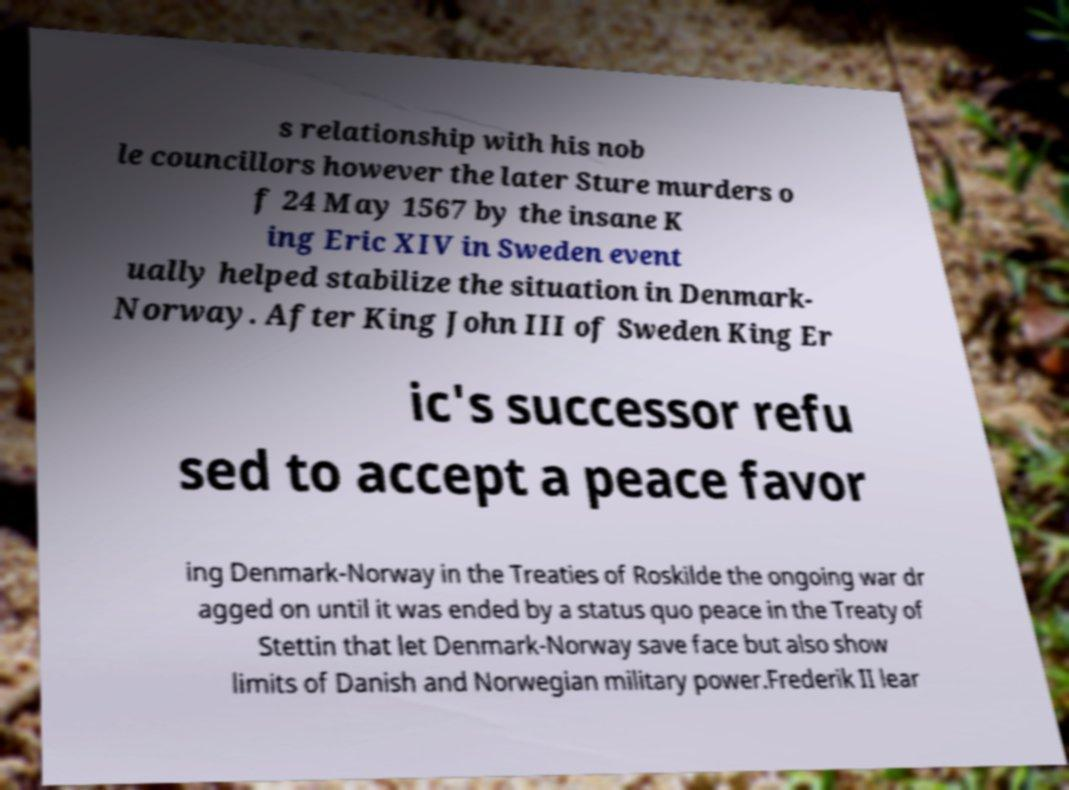Please read and relay the text visible in this image. What does it say? s relationship with his nob le councillors however the later Sture murders o f 24 May 1567 by the insane K ing Eric XIV in Sweden event ually helped stabilize the situation in Denmark- Norway. After King John III of Sweden King Er ic's successor refu sed to accept a peace favor ing Denmark-Norway in the Treaties of Roskilde the ongoing war dr agged on until it was ended by a status quo peace in the Treaty of Stettin that let Denmark-Norway save face but also show limits of Danish and Norwegian military power.Frederik II lear 